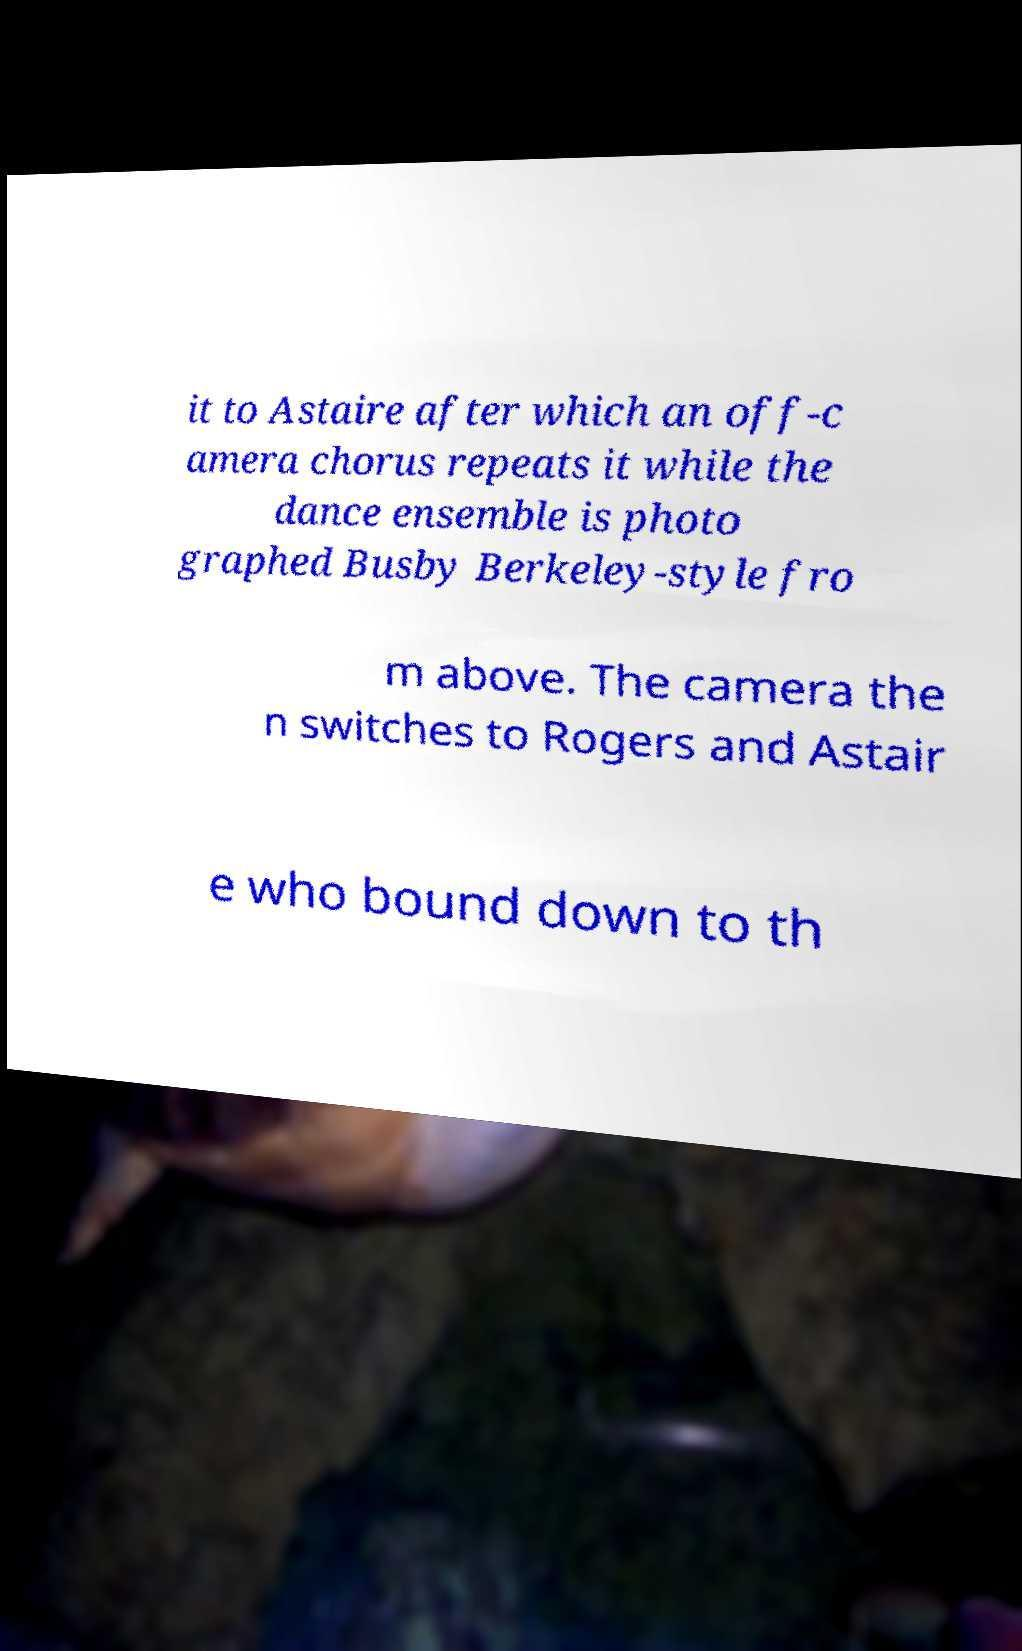There's text embedded in this image that I need extracted. Can you transcribe it verbatim? it to Astaire after which an off-c amera chorus repeats it while the dance ensemble is photo graphed Busby Berkeley-style fro m above. The camera the n switches to Rogers and Astair e who bound down to th 